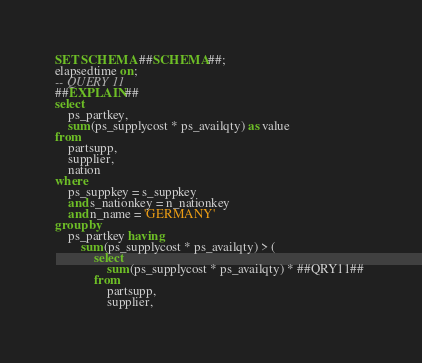Convert code to text. <code><loc_0><loc_0><loc_500><loc_500><_SQL_>SET SCHEMA ##SCHEMA##;
elapsedtime on;
-- QUERY 11
##EXPLAIN##
select
	ps_partkey,
	sum(ps_supplycost * ps_availqty) as value
from
	partsupp,
	supplier,
	nation
where
	ps_suppkey = s_suppkey
	and s_nationkey = n_nationkey
	and n_name = 'GERMANY'
group by
	ps_partkey having
		sum(ps_supplycost * ps_availqty) > (
			select
				sum(ps_supplycost * ps_availqty) * ##QRY11## 
			from
				partsupp,
				supplier,</code> 